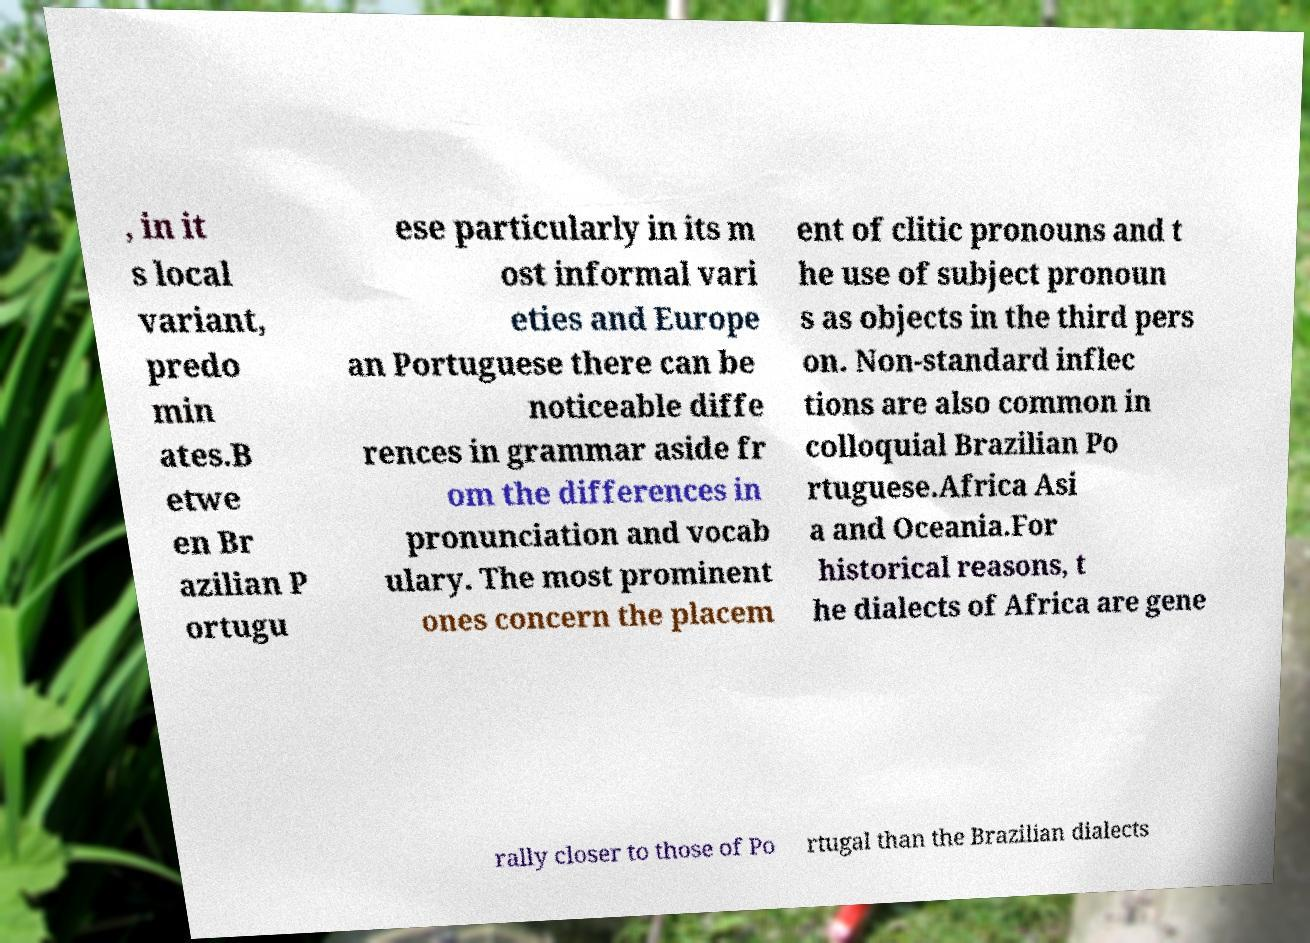What messages or text are displayed in this image? I need them in a readable, typed format. , in it s local variant, predo min ates.B etwe en Br azilian P ortugu ese particularly in its m ost informal vari eties and Europe an Portuguese there can be noticeable diffe rences in grammar aside fr om the differences in pronunciation and vocab ulary. The most prominent ones concern the placem ent of clitic pronouns and t he use of subject pronoun s as objects in the third pers on. Non-standard inflec tions are also common in colloquial Brazilian Po rtuguese.Africa Asi a and Oceania.For historical reasons, t he dialects of Africa are gene rally closer to those of Po rtugal than the Brazilian dialects 